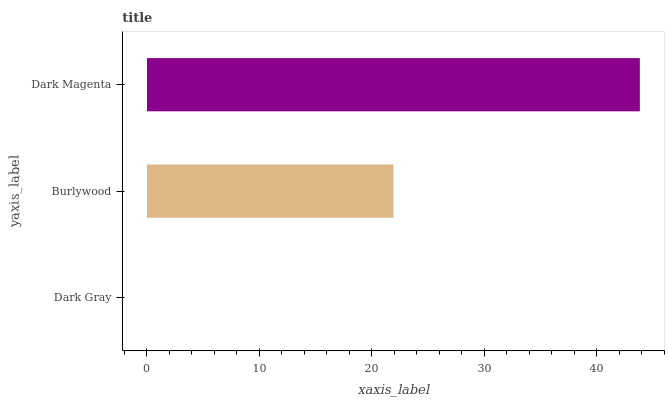Is Dark Gray the minimum?
Answer yes or no. Yes. Is Dark Magenta the maximum?
Answer yes or no. Yes. Is Burlywood the minimum?
Answer yes or no. No. Is Burlywood the maximum?
Answer yes or no. No. Is Burlywood greater than Dark Gray?
Answer yes or no. Yes. Is Dark Gray less than Burlywood?
Answer yes or no. Yes. Is Dark Gray greater than Burlywood?
Answer yes or no. No. Is Burlywood less than Dark Gray?
Answer yes or no. No. Is Burlywood the high median?
Answer yes or no. Yes. Is Burlywood the low median?
Answer yes or no. Yes. Is Dark Gray the high median?
Answer yes or no. No. Is Dark Gray the low median?
Answer yes or no. No. 